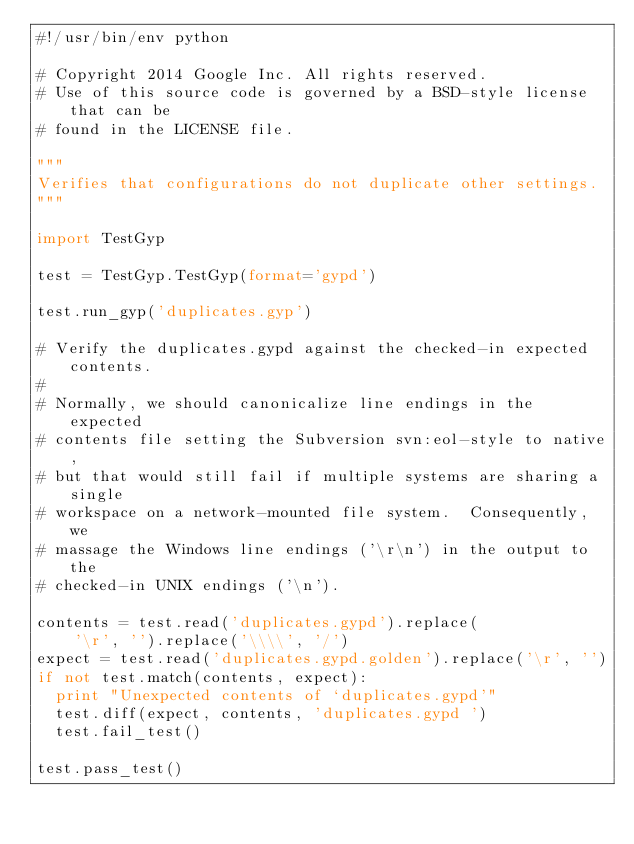<code> <loc_0><loc_0><loc_500><loc_500><_Python_>#!/usr/bin/env python

# Copyright 2014 Google Inc. All rights reserved.
# Use of this source code is governed by a BSD-style license that can be
# found in the LICENSE file.

"""
Verifies that configurations do not duplicate other settings.
"""

import TestGyp

test = TestGyp.TestGyp(format='gypd')

test.run_gyp('duplicates.gyp')

# Verify the duplicates.gypd against the checked-in expected contents.
#
# Normally, we should canonicalize line endings in the expected
# contents file setting the Subversion svn:eol-style to native,
# but that would still fail if multiple systems are sharing a single
# workspace on a network-mounted file system.  Consequently, we
# massage the Windows line endings ('\r\n') in the output to the
# checked-in UNIX endings ('\n').

contents = test.read('duplicates.gypd').replace(
    '\r', '').replace('\\\\', '/')
expect = test.read('duplicates.gypd.golden').replace('\r', '')
if not test.match(contents, expect):
  print "Unexpected contents of `duplicates.gypd'"
  test.diff(expect, contents, 'duplicates.gypd ')
  test.fail_test()

test.pass_test()
</code> 